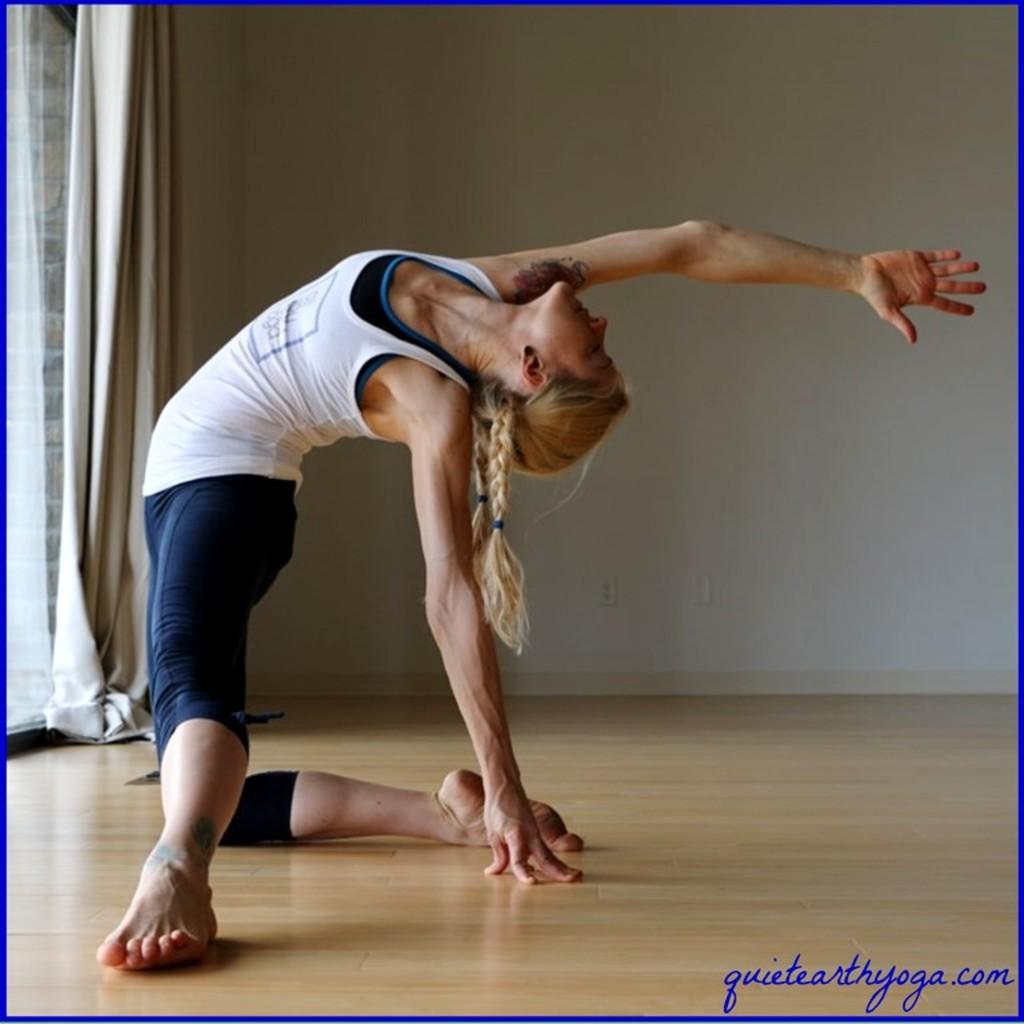What is the main subject of the image? The main subject of the image is a woman visible on the floor. What can be seen in the background of the image? There is a wall visible at the top of the image. What type of window treatment is present in the image? There is a white color curtain on the left side of the image. How many geese are flying over the woman in the image? There are no geese visible in the image. What type of baby is present in the image? There is no baby present in the image; it features a woman on the floor. 